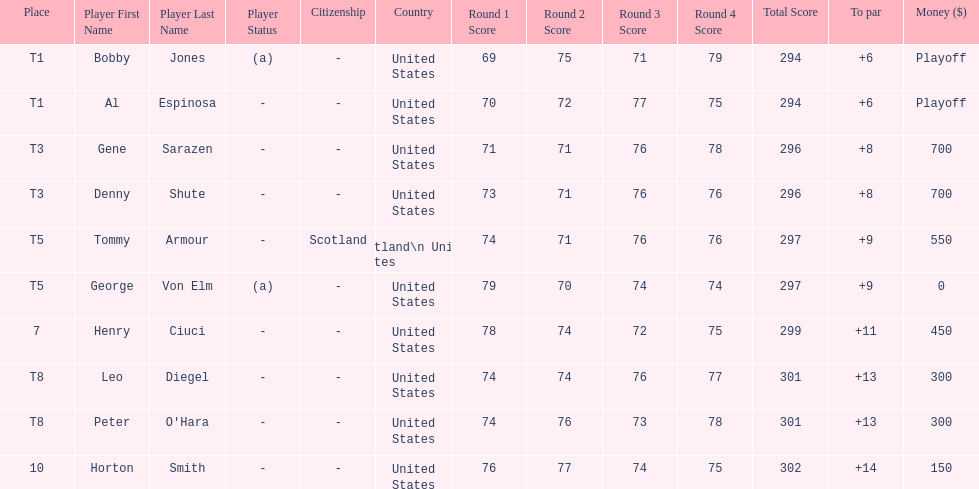Which two players tied for first place? Bobby Jones (a), Al Espinosa. 